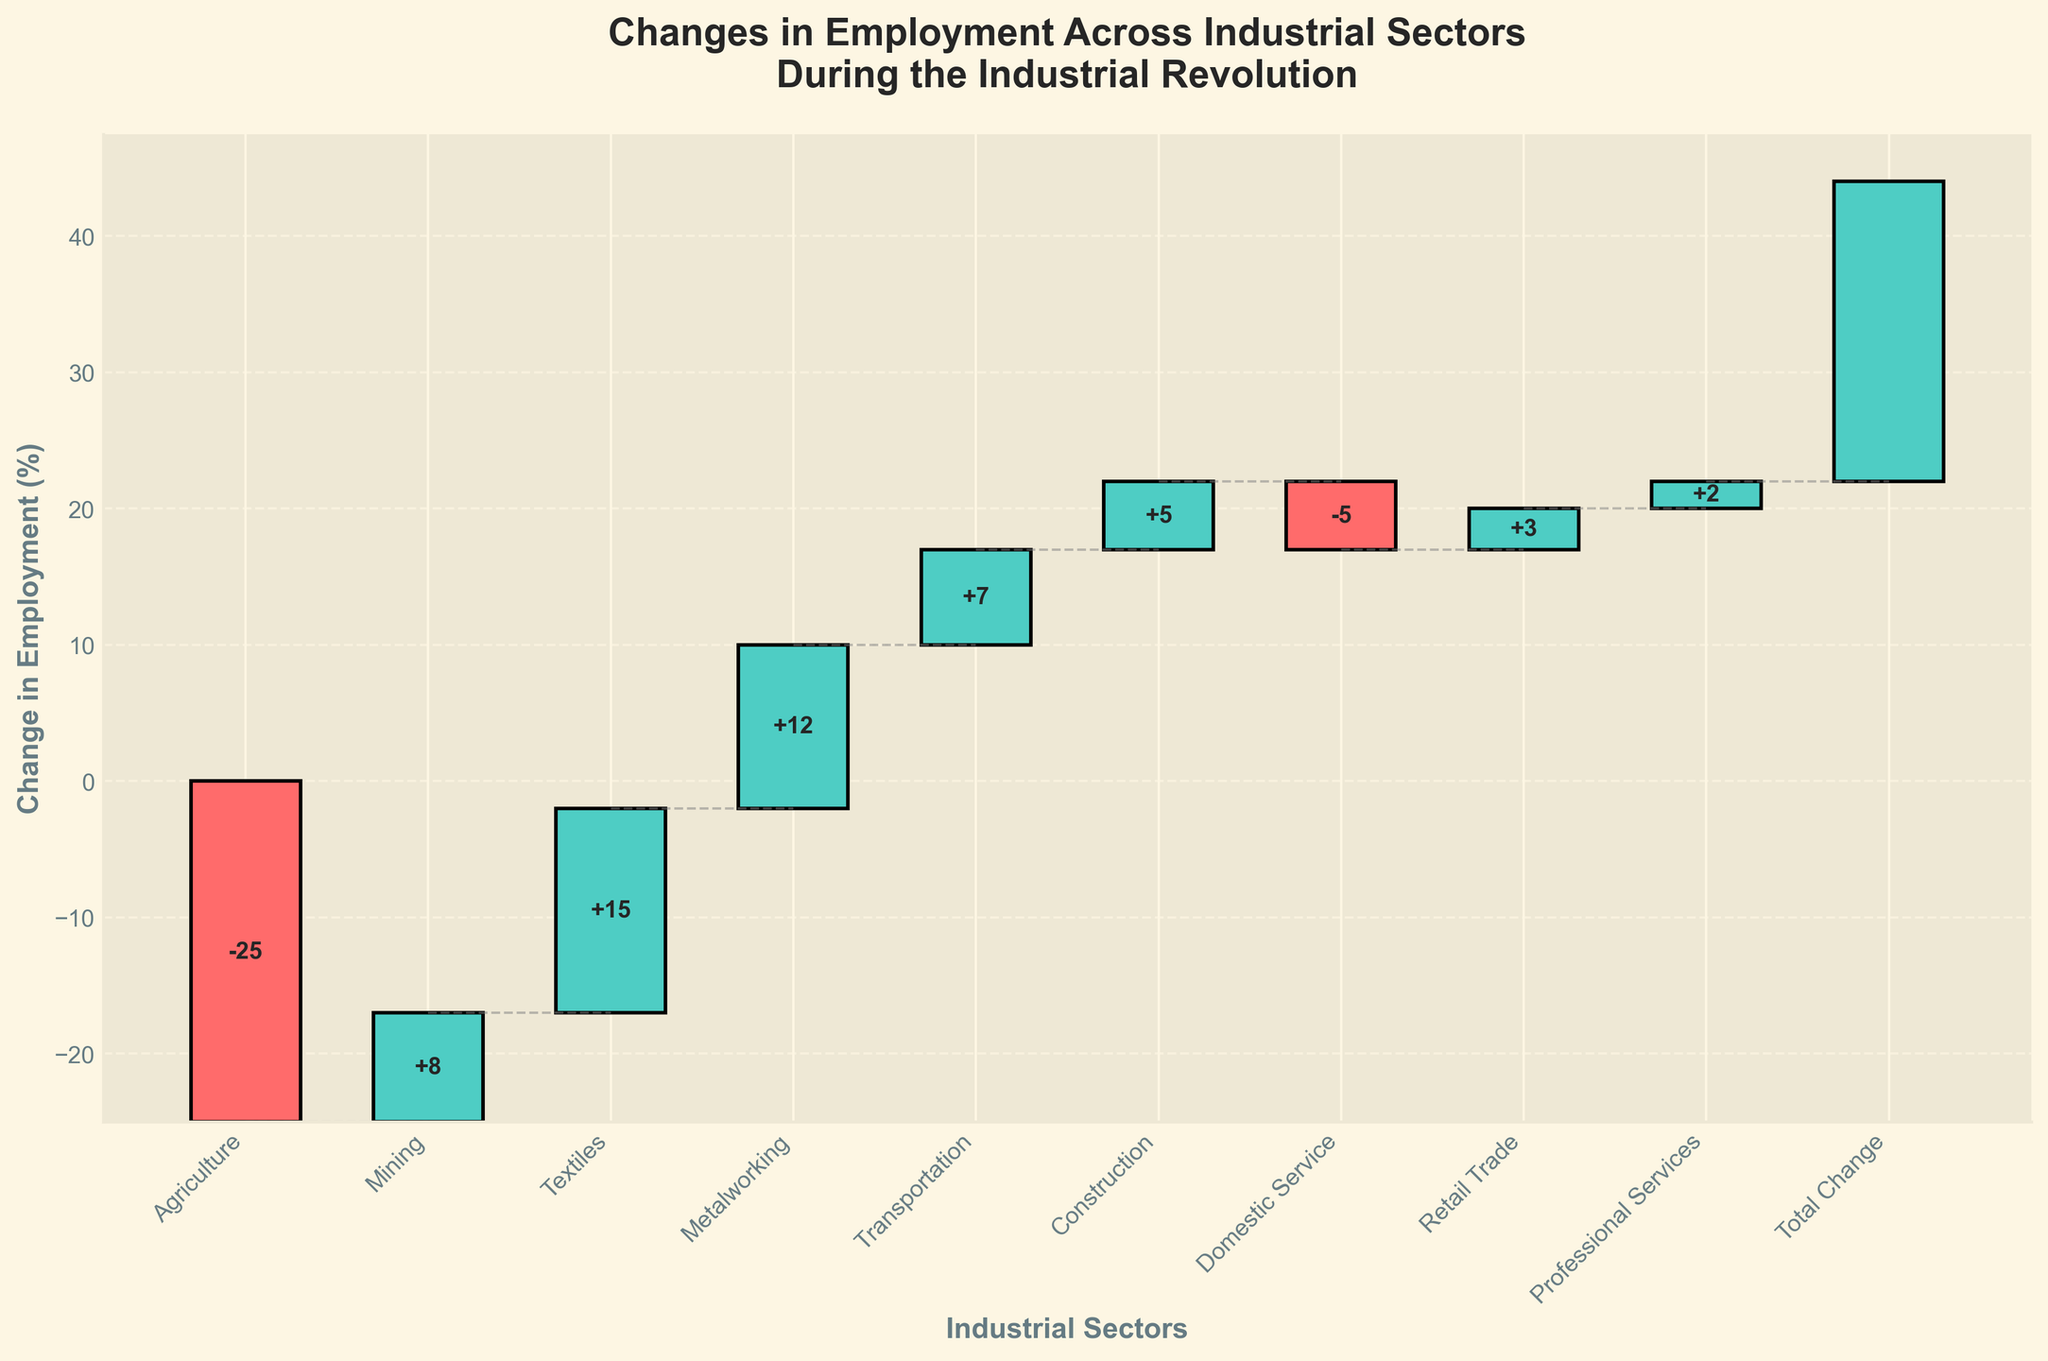What's the title of the chart? The title of the chart is displayed at the top of the figure and reads, "Changes in Employment Across Industrial Sectors During the Industrial Revolution"
Answer: Changes in Employment Across Industrial Sectors During the Industrial Revolution How much did employment in Agriculture change? Employment change for Agriculture can be read from the bar labeled "Agriculture". The text inside the bar shows a "+", indicating an increase, and the value "-25".
Answer: -25 Which sector experienced the largest increase in employment? To find the sector with the largest increase, we compare the positive changes shown in the bars. Textiles has the highest value, +15.
Answer: Textiles What is the overall change in employment across all sectors? The "Total Change" sector bar shows the overall change. The value is depicted inside the bar itself, "+22".
Answer: 22 How many sectors experienced a decrease in employment? The sectors with decreasing employment have bars colored differently from those with increases. Visual inspection shows Agriculture and Domestic Service as the decreasing sectors.
Answer: 2 What is the cumulative impact of changes in employment by the end of the Textiles sector? To find the cumulative impact up to Textiles, we sum the changes of Agriculture, Mining, and Textiles: (-25) + 8 + 15 = -2.
Answer: -2 What is the employment change in the Construction sector relative to Transportation? Employment change in Construction is shown as +5 and in Transportation as +7. Comparing both figures: +7 - +5 = +2, showing Transportation had 2 more.
Answer: 2 Which sector contributed the least to the overall employment change, and what is that change? We identify the sector with the smallest absolute change. Professional Services shows the smallest value, +2.
Answer: Professional Services, +2 How does the change in Domestic Service compare to Retail Trade? The change in Domestic Service is -5 and in Retail Trade is +3. Since -5 is less than +3, Domestic Service decreased while Retail Trade increased. Calculating their numerical difference: -5 - 3 = -8
Answer: -8 Why do sectors with negative employment changes have a different color? In the waterfall chart, sectors with negative employment changes are differentiated by color to help visually distinguish decreases from increases.
Answer: To distinguish declines visually 